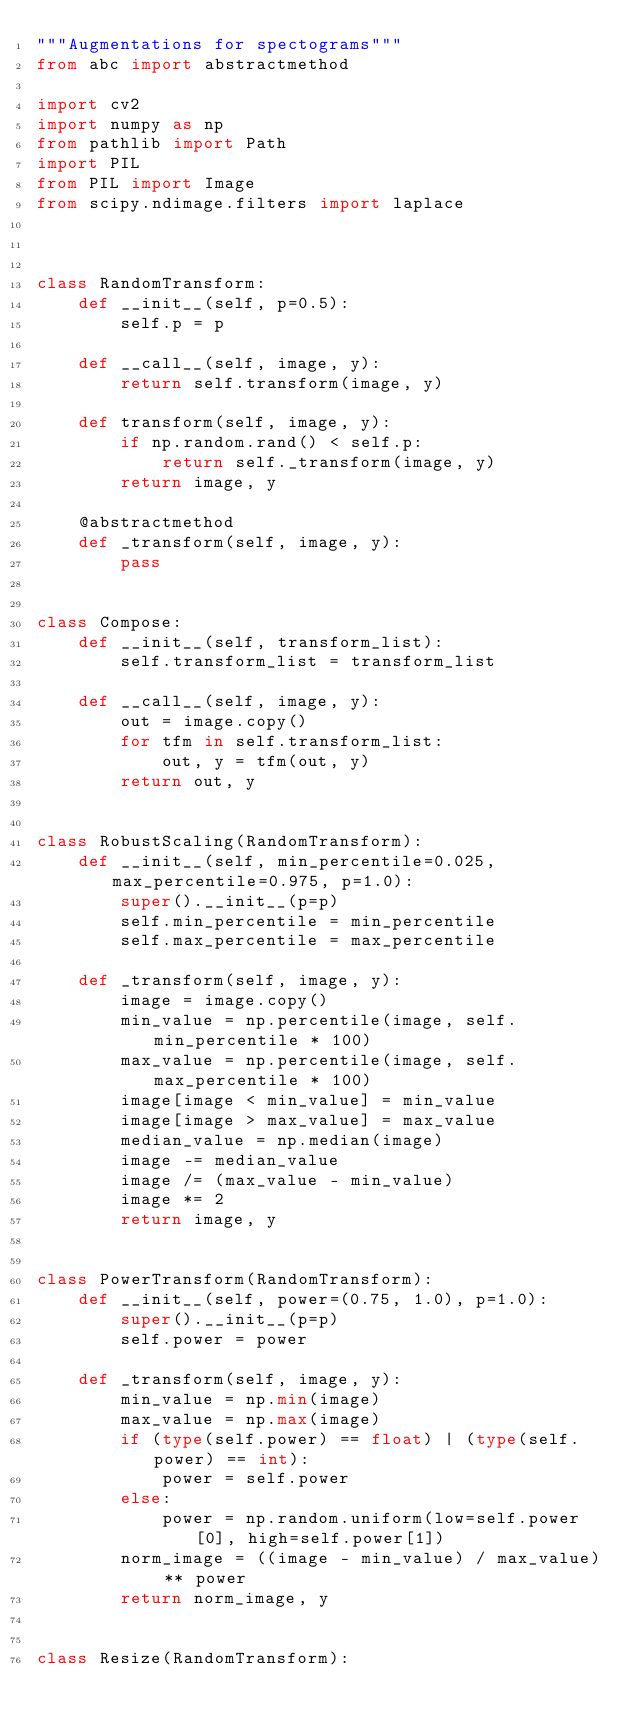Convert code to text. <code><loc_0><loc_0><loc_500><loc_500><_Python_>"""Augmentations for spectograms"""
from abc import abstractmethod

import cv2
import numpy as np
from pathlib import Path
import PIL
from PIL import Image
from scipy.ndimage.filters import laplace



class RandomTransform:
    def __init__(self, p=0.5):
        self.p = p

    def __call__(self, image, y):
        return self.transform(image, y)

    def transform(self, image, y):
        if np.random.rand() < self.p:
            return self._transform(image, y)
        return image, y

    @abstractmethod
    def _transform(self, image, y):
        pass


class Compose:
    def __init__(self, transform_list):
        self.transform_list = transform_list

    def __call__(self, image, y):
        out = image.copy()
        for tfm in self.transform_list:
            out, y = tfm(out, y)
        return out, y


class RobustScaling(RandomTransform):
    def __init__(self, min_percentile=0.025, max_percentile=0.975, p=1.0):
        super().__init__(p=p)
        self.min_percentile = min_percentile
        self.max_percentile = max_percentile

    def _transform(self, image, y):
        image = image.copy()
        min_value = np.percentile(image, self.min_percentile * 100)
        max_value = np.percentile(image, self.max_percentile * 100)
        image[image < min_value] = min_value
        image[image > max_value] = max_value
        median_value = np.median(image)
        image -= median_value
        image /= (max_value - min_value)
        image *= 2
        return image, y


class PowerTransform(RandomTransform):
    def __init__(self, power=(0.75, 1.0), p=1.0):
        super().__init__(p=p)
        self.power = power

    def _transform(self, image, y):
        min_value = np.min(image)
        max_value = np.max(image)
        if (type(self.power) == float) | (type(self.power) == int):
            power = self.power
        else:
            power = np.random.uniform(low=self.power[0], high=self.power[1])
        norm_image = ((image - min_value) / max_value) ** power
        return norm_image, y


class Resize(RandomTransform):</code> 